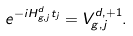<formula> <loc_0><loc_0><loc_500><loc_500>e ^ { - i H ^ { d } _ { g , j } t _ { j } } = V ^ { d , + 1 } _ { g , j } .</formula> 